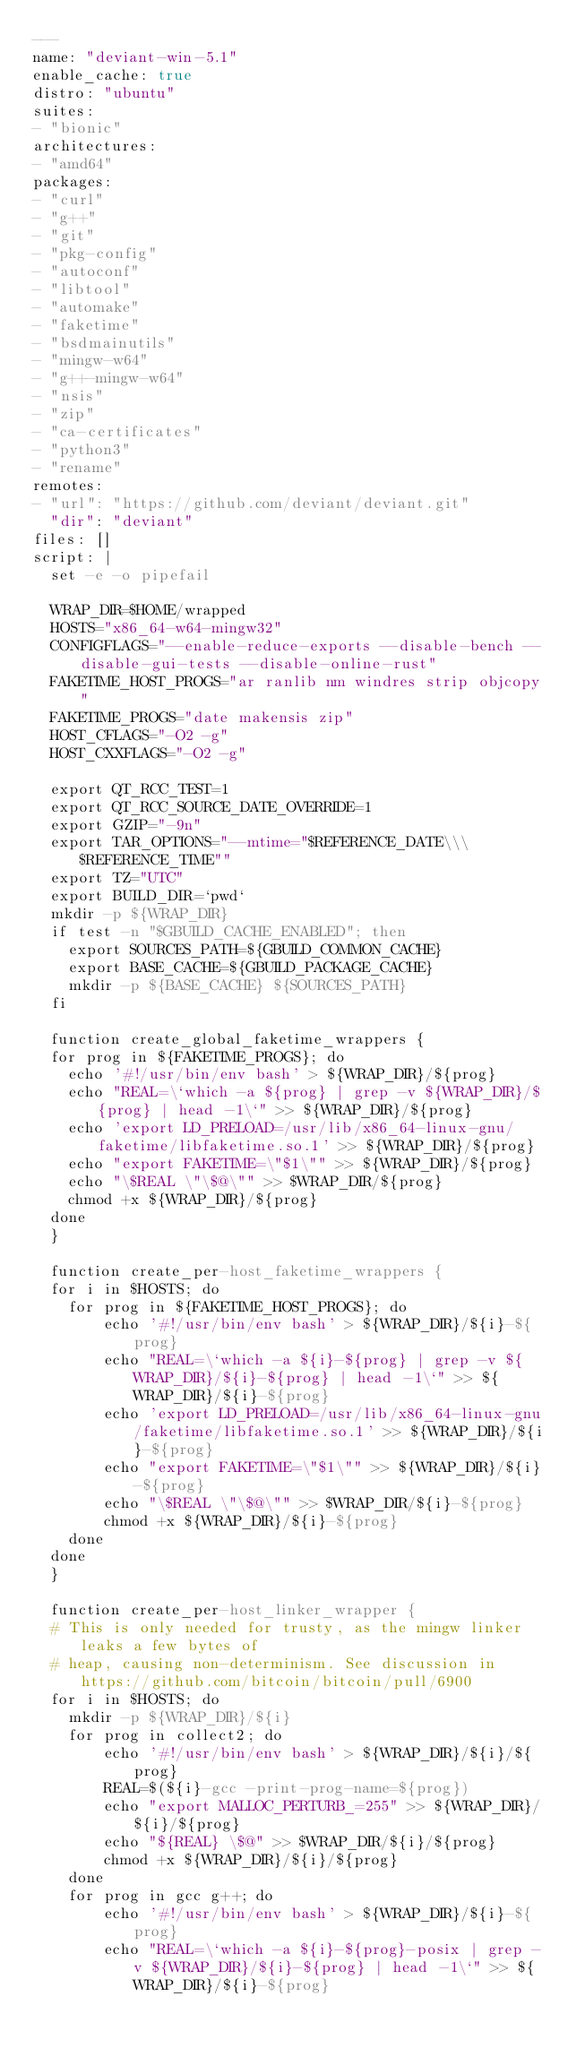Convert code to text. <code><loc_0><loc_0><loc_500><loc_500><_YAML_>---
name: "deviant-win-5.1"
enable_cache: true
distro: "ubuntu"
suites:
- "bionic"
architectures:
- "amd64"
packages:
- "curl"
- "g++"
- "git"
- "pkg-config"
- "autoconf"
- "libtool"
- "automake"
- "faketime"
- "bsdmainutils"
- "mingw-w64"
- "g++-mingw-w64"
- "nsis"
- "zip"
- "ca-certificates"
- "python3"
- "rename"
remotes:
- "url": "https://github.com/deviant/deviant.git"
  "dir": "deviant"
files: []
script: |
  set -e -o pipefail

  WRAP_DIR=$HOME/wrapped
  HOSTS="x86_64-w64-mingw32"
  CONFIGFLAGS="--enable-reduce-exports --disable-bench --disable-gui-tests --disable-online-rust"
  FAKETIME_HOST_PROGS="ar ranlib nm windres strip objcopy"
  FAKETIME_PROGS="date makensis zip"
  HOST_CFLAGS="-O2 -g"
  HOST_CXXFLAGS="-O2 -g"

  export QT_RCC_TEST=1
  export QT_RCC_SOURCE_DATE_OVERRIDE=1
  export GZIP="-9n"
  export TAR_OPTIONS="--mtime="$REFERENCE_DATE\\\ $REFERENCE_TIME""
  export TZ="UTC"
  export BUILD_DIR=`pwd`
  mkdir -p ${WRAP_DIR}
  if test -n "$GBUILD_CACHE_ENABLED"; then
    export SOURCES_PATH=${GBUILD_COMMON_CACHE}
    export BASE_CACHE=${GBUILD_PACKAGE_CACHE}
    mkdir -p ${BASE_CACHE} ${SOURCES_PATH}
  fi

  function create_global_faketime_wrappers {
  for prog in ${FAKETIME_PROGS}; do
    echo '#!/usr/bin/env bash' > ${WRAP_DIR}/${prog}
    echo "REAL=\`which -a ${prog} | grep -v ${WRAP_DIR}/${prog} | head -1\`" >> ${WRAP_DIR}/${prog}
    echo 'export LD_PRELOAD=/usr/lib/x86_64-linux-gnu/faketime/libfaketime.so.1' >> ${WRAP_DIR}/${prog}
    echo "export FAKETIME=\"$1\"" >> ${WRAP_DIR}/${prog}
    echo "\$REAL \"\$@\"" >> $WRAP_DIR/${prog}
    chmod +x ${WRAP_DIR}/${prog}
  done
  }

  function create_per-host_faketime_wrappers {
  for i in $HOSTS; do
    for prog in ${FAKETIME_HOST_PROGS}; do
        echo '#!/usr/bin/env bash' > ${WRAP_DIR}/${i}-${prog}
        echo "REAL=\`which -a ${i}-${prog} | grep -v ${WRAP_DIR}/${i}-${prog} | head -1\`" >> ${WRAP_DIR}/${i}-${prog}
        echo 'export LD_PRELOAD=/usr/lib/x86_64-linux-gnu/faketime/libfaketime.so.1' >> ${WRAP_DIR}/${i}-${prog}
        echo "export FAKETIME=\"$1\"" >> ${WRAP_DIR}/${i}-${prog}
        echo "\$REAL \"\$@\"" >> $WRAP_DIR/${i}-${prog}
        chmod +x ${WRAP_DIR}/${i}-${prog}
    done
  done
  }

  function create_per-host_linker_wrapper {
  # This is only needed for trusty, as the mingw linker leaks a few bytes of
  # heap, causing non-determinism. See discussion in https://github.com/bitcoin/bitcoin/pull/6900
  for i in $HOSTS; do
    mkdir -p ${WRAP_DIR}/${i}
    for prog in collect2; do
        echo '#!/usr/bin/env bash' > ${WRAP_DIR}/${i}/${prog}
        REAL=$(${i}-gcc -print-prog-name=${prog})
        echo "export MALLOC_PERTURB_=255" >> ${WRAP_DIR}/${i}/${prog}
        echo "${REAL} \$@" >> $WRAP_DIR/${i}/${prog}
        chmod +x ${WRAP_DIR}/${i}/${prog}
    done
    for prog in gcc g++; do
        echo '#!/usr/bin/env bash' > ${WRAP_DIR}/${i}-${prog}
        echo "REAL=\`which -a ${i}-${prog}-posix | grep -v ${WRAP_DIR}/${i}-${prog} | head -1\`" >> ${WRAP_DIR}/${i}-${prog}</code> 